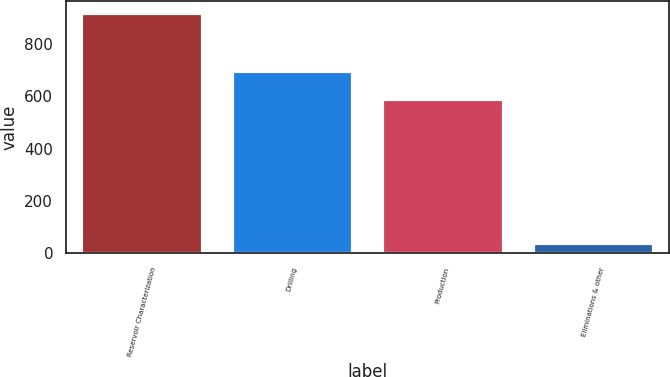Convert chart to OTSL. <chart><loc_0><loc_0><loc_500><loc_500><bar_chart><fcel>Reservoir Characterization<fcel>Drilling<fcel>Production<fcel>Eliminations & other<nl><fcel>917<fcel>696<fcel>590<fcel>39<nl></chart> 